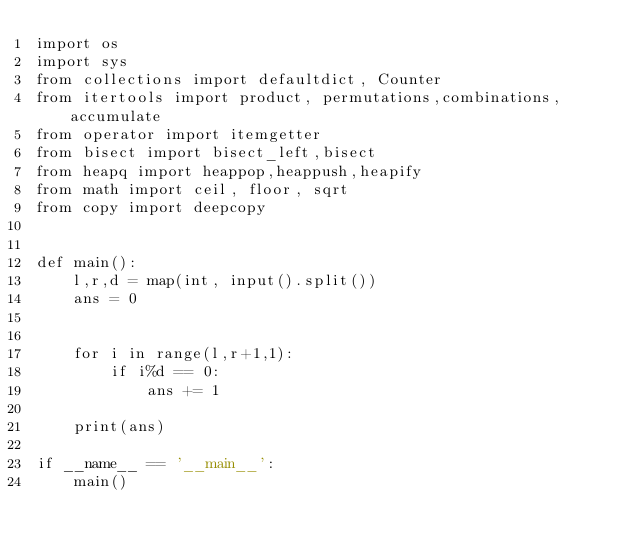Convert code to text. <code><loc_0><loc_0><loc_500><loc_500><_Python_>import os
import sys
from collections import defaultdict, Counter
from itertools import product, permutations,combinations, accumulate
from operator import itemgetter
from bisect import bisect_left,bisect
from heapq import heappop,heappush,heapify
from math import ceil, floor, sqrt
from copy import deepcopy


def main():
    l,r,d = map(int, input().split())
    ans = 0


    for i in range(l,r+1,1):
        if i%d == 0:
            ans += 1

    print(ans)

if __name__ == '__main__':
	main()
</code> 